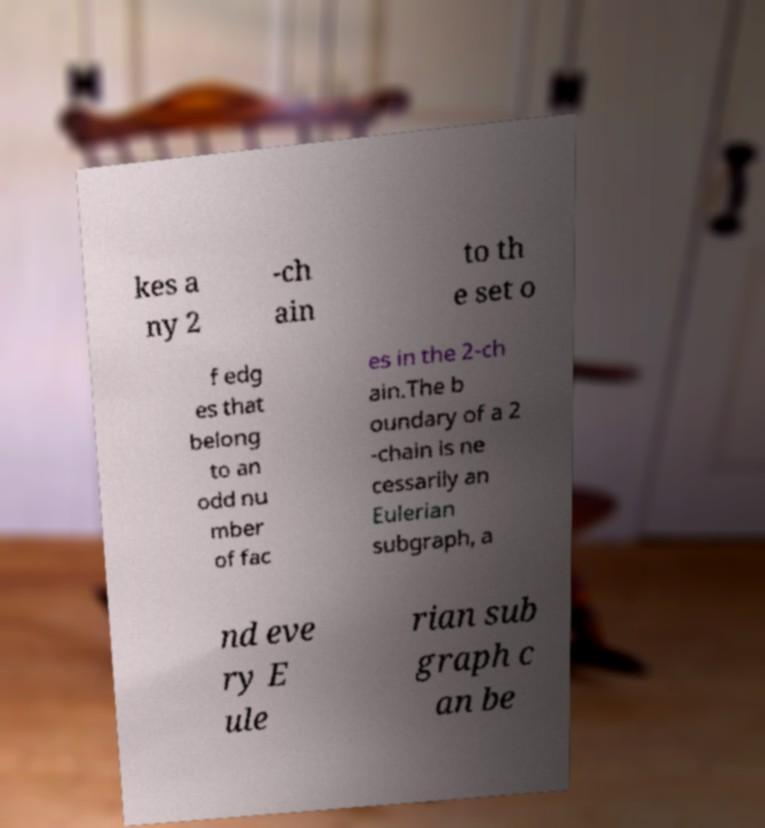Please read and relay the text visible in this image. What does it say? kes a ny 2 -ch ain to th e set o f edg es that belong to an odd nu mber of fac es in the 2-ch ain.The b oundary of a 2 -chain is ne cessarily an Eulerian subgraph, a nd eve ry E ule rian sub graph c an be 